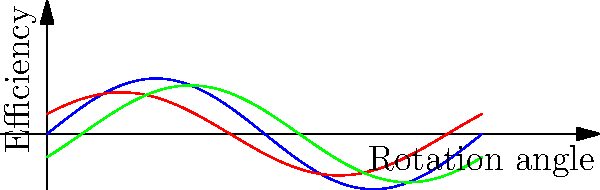In the context of wireless communication infrastructure, which gear tooth profile would likely result in the most energy-efficient power transmission for remote base stations, potentially reducing the overall carbon footprint of the network? To answer this question, we need to consider the efficiency of different gear tooth profiles in power transmission:

1. Involute profile (blue line):
   - Most common in modern gearing
   - Maintains a constant pressure angle during mesh
   - Relatively easy to manufacture
   - Efficiency typically ranges from 96% to 99%

2. Cycloidal profile (red line):
   - Used in watchmaking and some specialized applications
   - Provides smooth motion but more complex to manufacture
   - Efficiency can be high but generally lower than involute, around 94% to 97%

3. Straight profile (green line):
   - Simplest to manufacture but least efficient
   - Prone to wear and vibration
   - Efficiency typically ranges from 90% to 95%

For remote base stations in wireless communication infrastructure:

1. Energy efficiency is crucial to reduce operational costs and environmental impact.
2. Reliability is important to minimize maintenance requirements in remote locations.
3. Longevity of components helps reduce the need for frequent replacements.

Considering these factors, the involute gear tooth profile would be the most suitable choice:

- It offers the highest efficiency among the three profiles, which directly translates to energy savings.
- Its widespread use means easier maintenance and replacement if needed.
- The constant pressure angle during mesh results in smoother operation and less wear, increasing longevity.

By choosing the involute profile for power transmission in remote base stations, network operators can maximize energy efficiency, potentially reducing the overall carbon footprint of the wireless communication infrastructure.
Answer: Involute gear tooth profile 